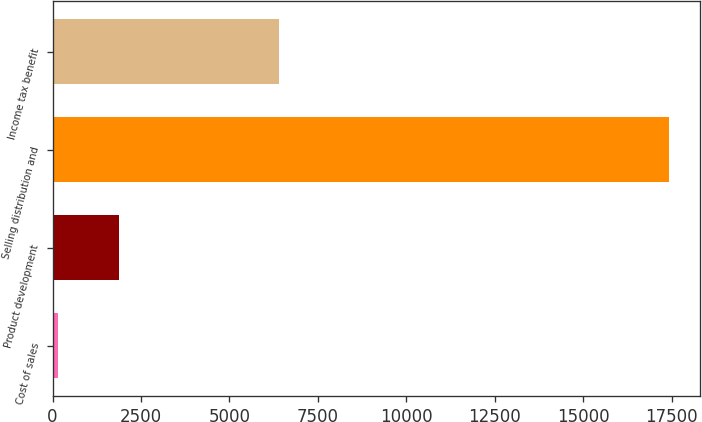Convert chart to OTSL. <chart><loc_0><loc_0><loc_500><loc_500><bar_chart><fcel>Cost of sales<fcel>Product development<fcel>Selling distribution and<fcel>Income tax benefit<nl><fcel>146<fcel>1874.8<fcel>17434<fcel>6392<nl></chart> 